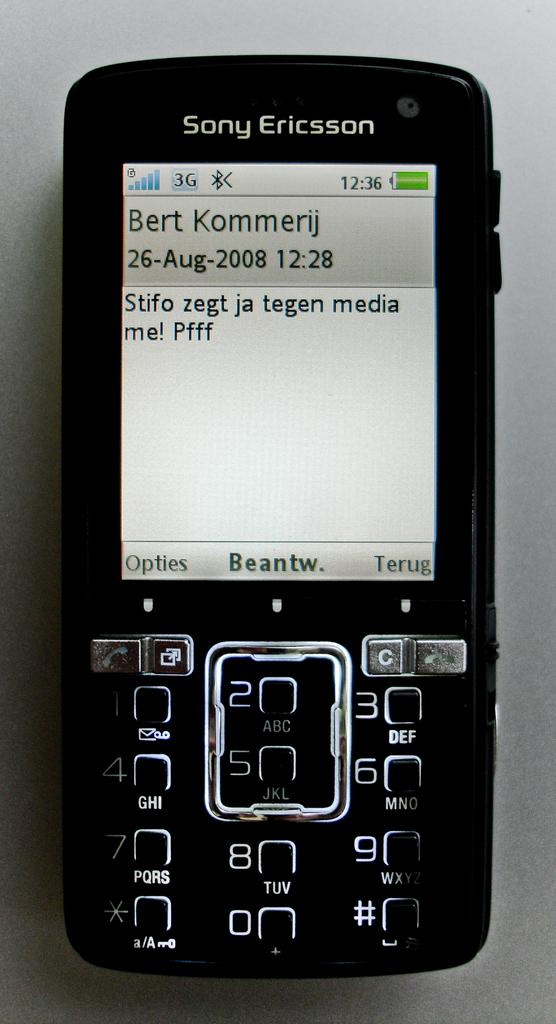Provide a one-sentence caption for the provided image. The owner of this Sony Ericsson phone has sent a message to,or received a message from Bert Kommerij. 